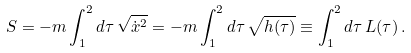<formula> <loc_0><loc_0><loc_500><loc_500>S = - m \int _ { 1 } ^ { 2 } d \tau \, \sqrt { \dot { x } ^ { 2 } } = - m \int _ { 1 } ^ { 2 } d \tau \, \sqrt { h ( \tau ) } \equiv \int _ { 1 } ^ { 2 } d \tau \, L ( \tau ) \, .</formula> 